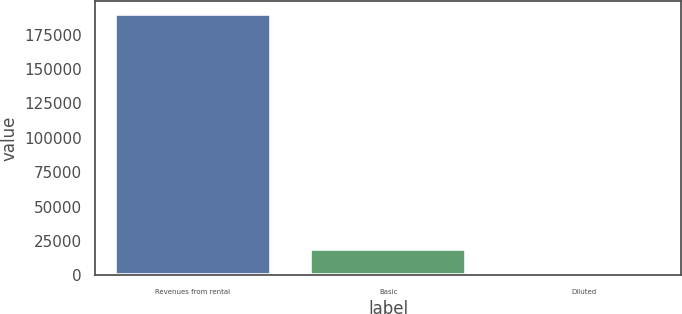<chart> <loc_0><loc_0><loc_500><loc_500><bar_chart><fcel>Revenues from rental<fcel>Basic<fcel>Diluted<nl><fcel>189951<fcel>18995.4<fcel>0.37<nl></chart> 